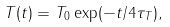<formula> <loc_0><loc_0><loc_500><loc_500>T ( t ) = T _ { 0 } \exp ( - t / 4 \tau _ { T } ) ,</formula> 